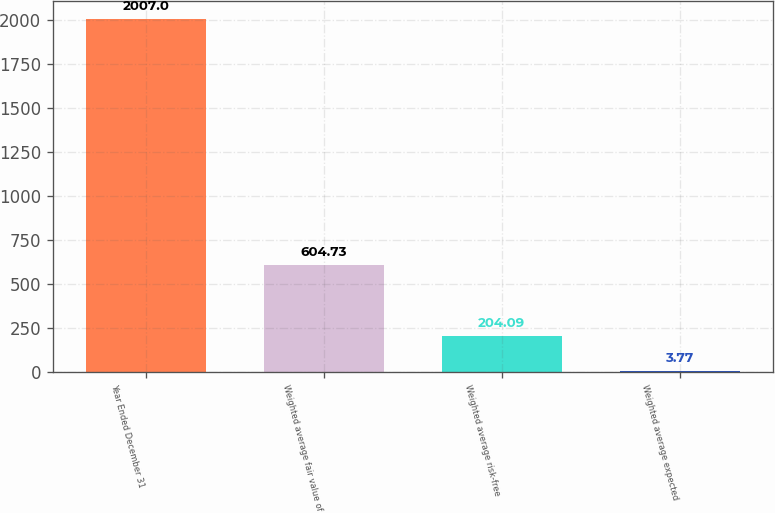<chart> <loc_0><loc_0><loc_500><loc_500><bar_chart><fcel>Year Ended December 31<fcel>Weighted average fair value of<fcel>Weighted average risk-free<fcel>Weighted average expected<nl><fcel>2007<fcel>604.73<fcel>204.09<fcel>3.77<nl></chart> 